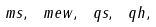<formula> <loc_0><loc_0><loc_500><loc_500>\ m s , \ m e w , \ q s , \ q h ,</formula> 